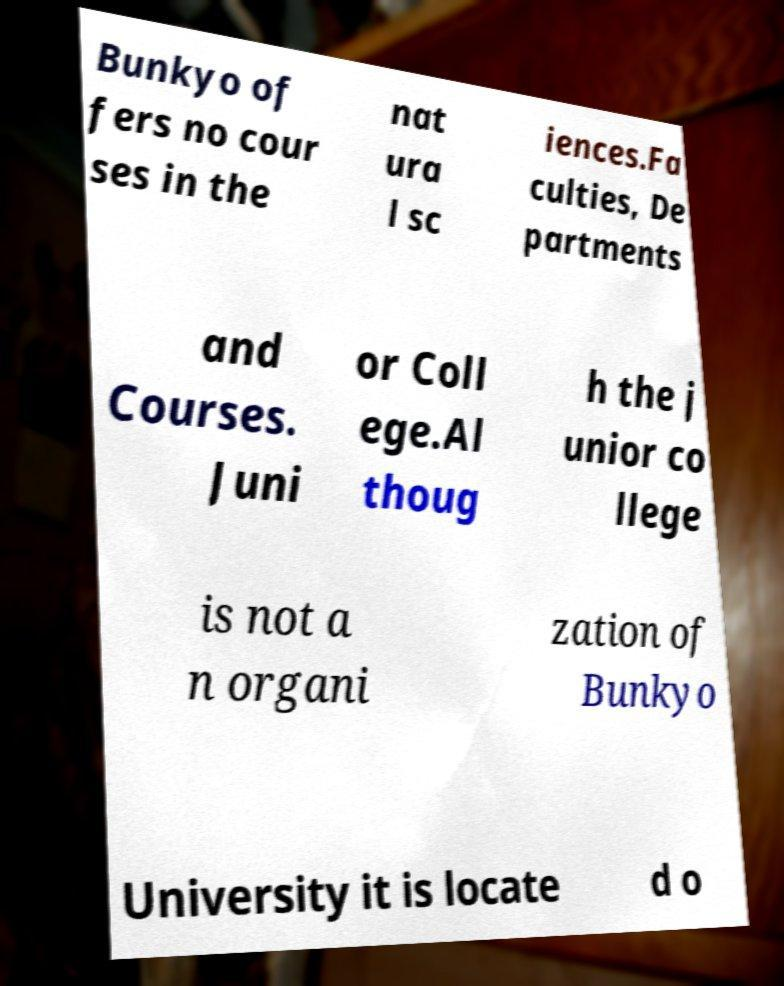Can you accurately transcribe the text from the provided image for me? Bunkyo of fers no cour ses in the nat ura l sc iences.Fa culties, De partments and Courses. Juni or Coll ege.Al thoug h the j unior co llege is not a n organi zation of Bunkyo University it is locate d o 